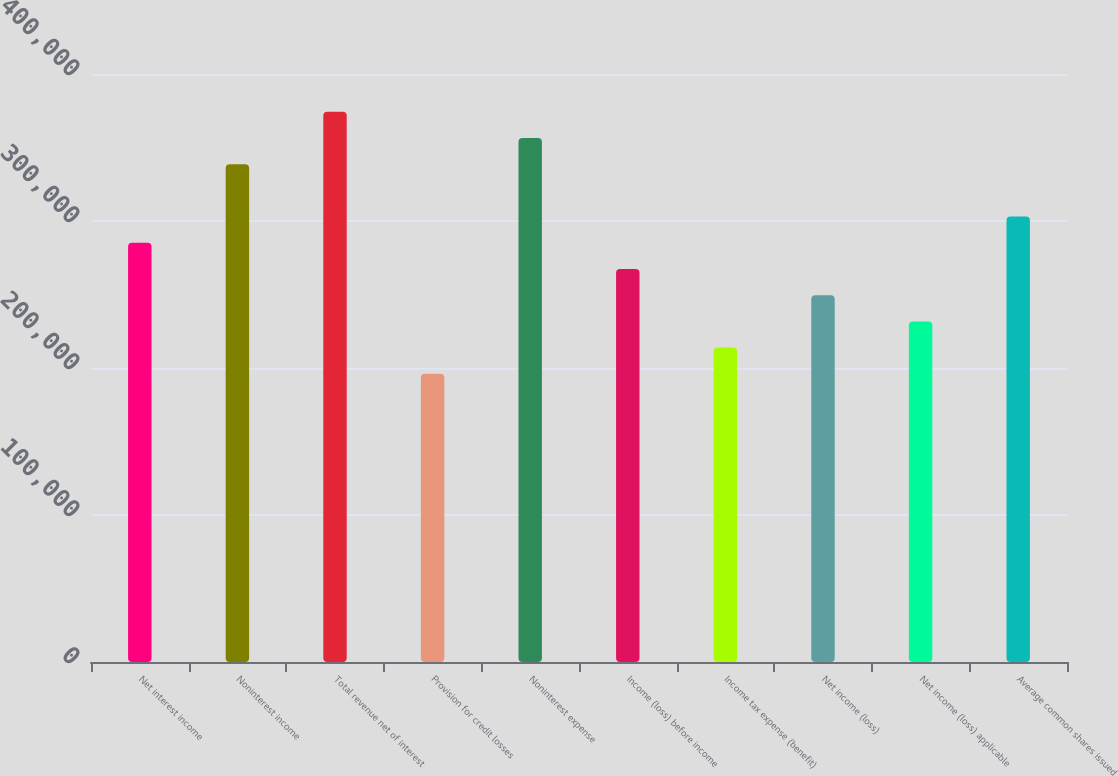Convert chart. <chart><loc_0><loc_0><loc_500><loc_500><bar_chart><fcel>Net interest income<fcel>Noninterest income<fcel>Total revenue net of interest<fcel>Provision for credit losses<fcel>Noninterest expense<fcel>Income (loss) before income<fcel>Income tax expense (benefit)<fcel>Net income (loss)<fcel>Net income (loss) applicable<fcel>Average common shares issued<nl><fcel>285170<fcel>338639<fcel>374285<fcel>196054<fcel>356462<fcel>267346<fcel>213877<fcel>249523<fcel>231700<fcel>302993<nl></chart> 